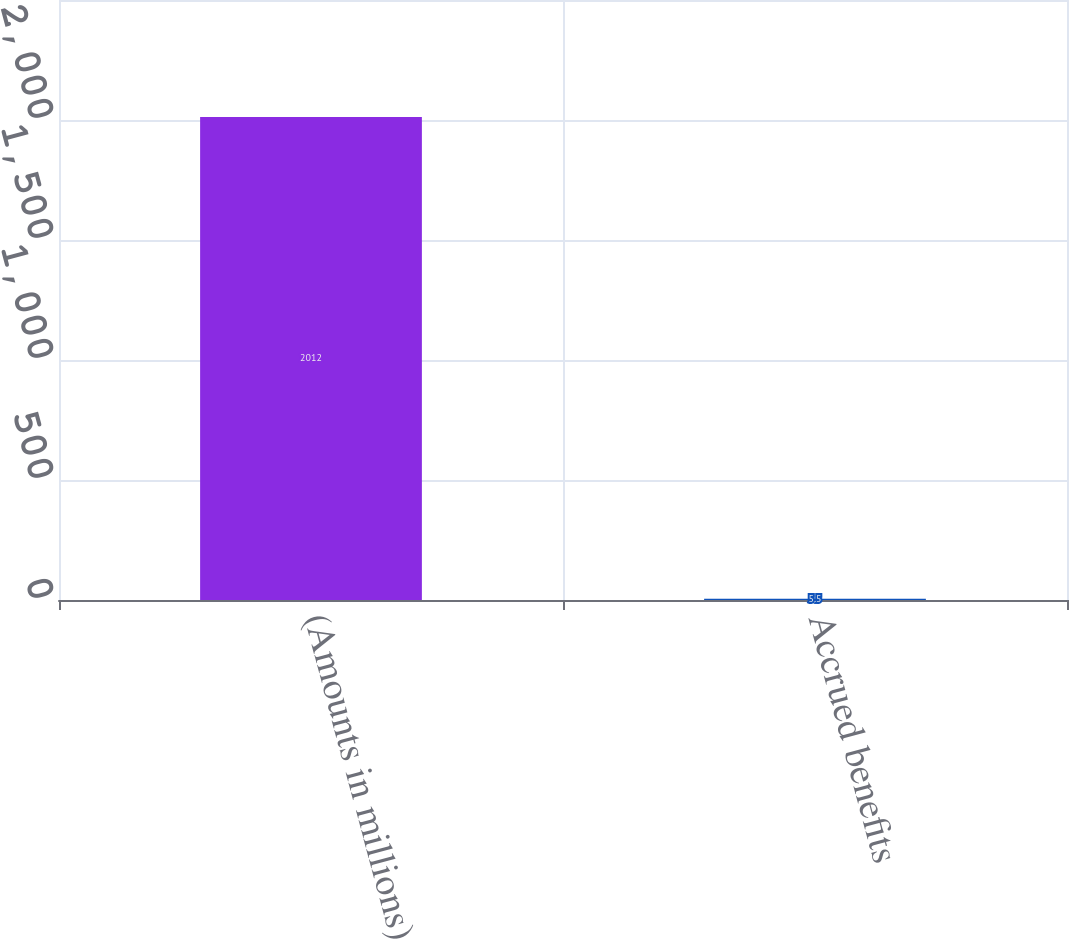Convert chart. <chart><loc_0><loc_0><loc_500><loc_500><bar_chart><fcel>(Amounts in millions)<fcel>Accrued benefits<nl><fcel>2012<fcel>5.5<nl></chart> 